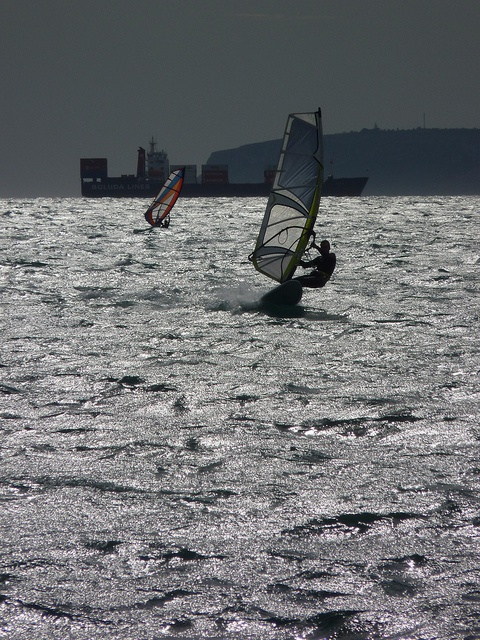Describe the objects in this image and their specific colors. I can see boat in gray, black, and darkgray tones, boat in gray, black, and purple tones, people in gray, black, darkgray, and purple tones, boat in gray, black, maroon, and navy tones, and surfboard in gray, black, purple, and darkgray tones in this image. 